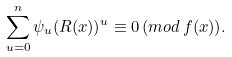<formula> <loc_0><loc_0><loc_500><loc_500>\sum _ { u = 0 } ^ { n } \psi _ { u } ( R ( x ) ) ^ { u } \equiv 0 \, ( m o d \, f ( x ) ) .</formula> 